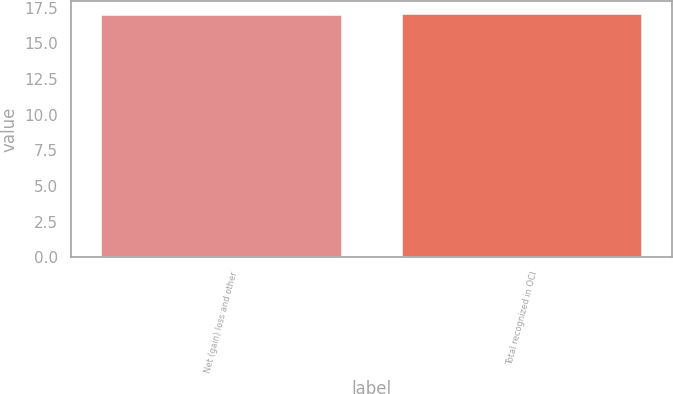Convert chart. <chart><loc_0><loc_0><loc_500><loc_500><bar_chart><fcel>Net (gain) loss and other<fcel>Total recognized in OCI<nl><fcel>17<fcel>17.1<nl></chart> 